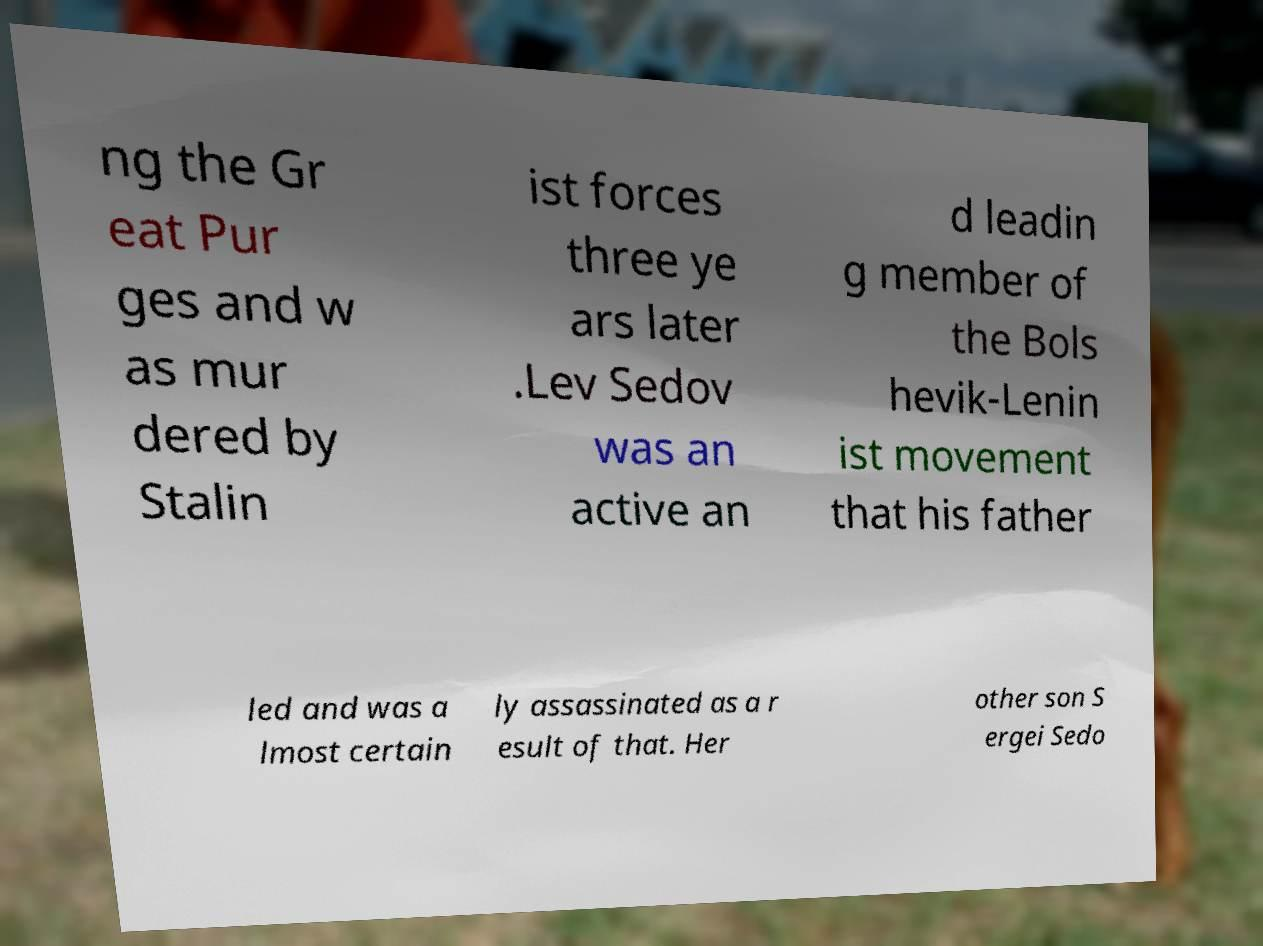Can you accurately transcribe the text from the provided image for me? ng the Gr eat Pur ges and w as mur dered by Stalin ist forces three ye ars later .Lev Sedov was an active an d leadin g member of the Bols hevik-Lenin ist movement that his father led and was a lmost certain ly assassinated as a r esult of that. Her other son S ergei Sedo 